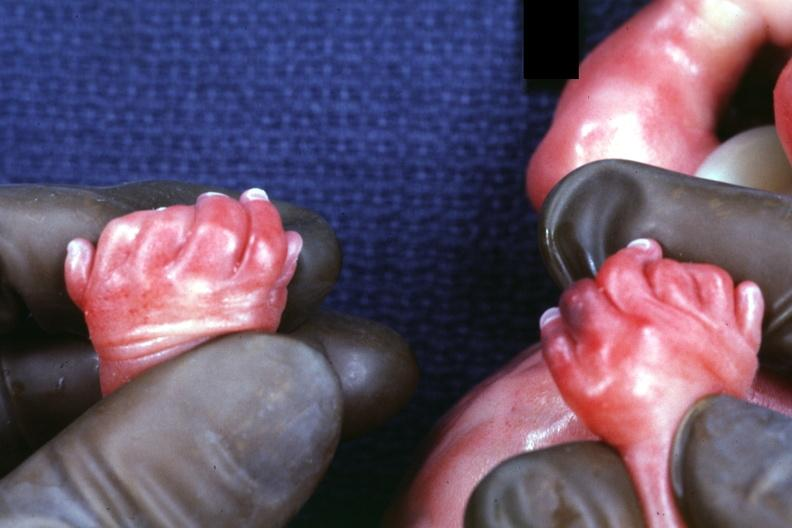does this image show child has polycystic disease?
Answer the question using a single word or phrase. Yes 